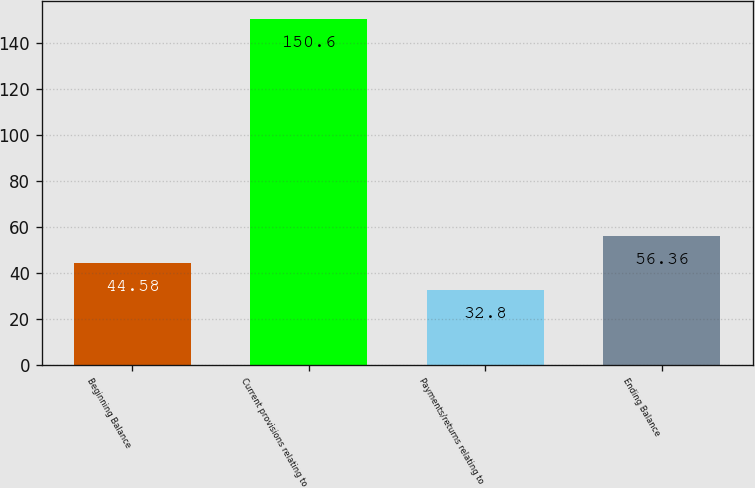Convert chart. <chart><loc_0><loc_0><loc_500><loc_500><bar_chart><fcel>Beginning Balance<fcel>Current provisions relating to<fcel>Payments/returns relating to<fcel>Ending Balance<nl><fcel>44.58<fcel>150.6<fcel>32.8<fcel>56.36<nl></chart> 